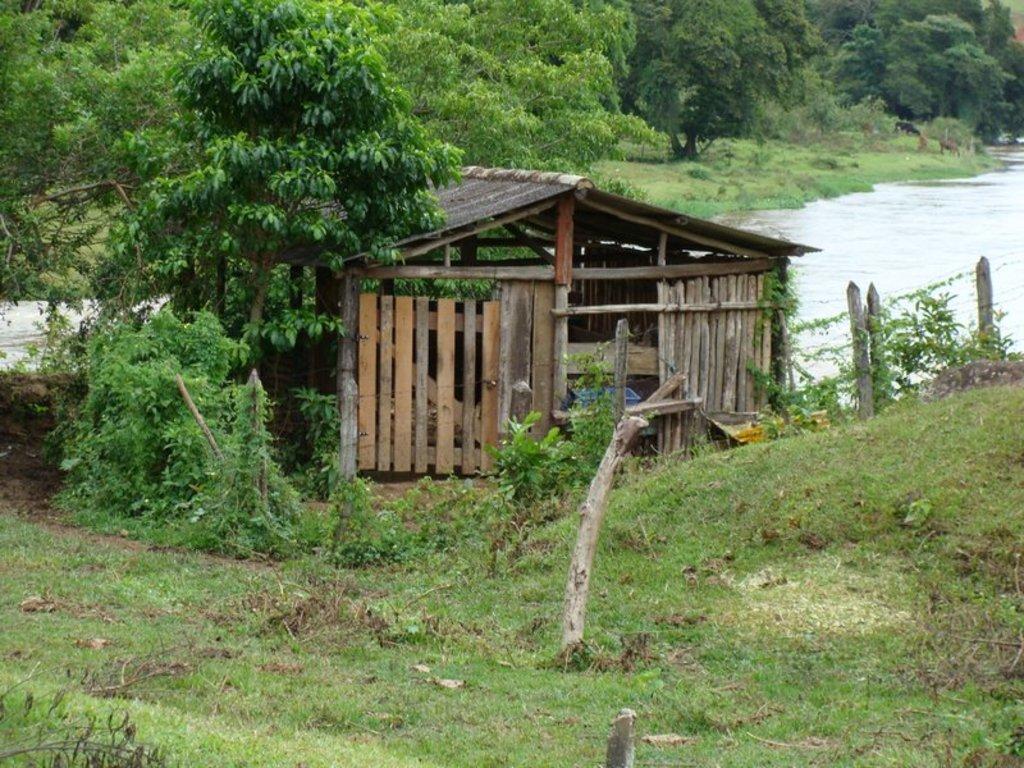Please provide a concise description of this image. In this picture is a wooden shed house on the ground. Behind we can see many trees. On the rights side there is a small river. In the front side there is a grass on the ground. 